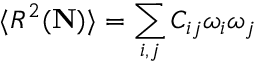<formula> <loc_0><loc_0><loc_500><loc_500>\langle R ^ { 2 } ( { N } ) \rangle = \sum _ { i , j } C _ { i j } \omega _ { i } \omega _ { j }</formula> 